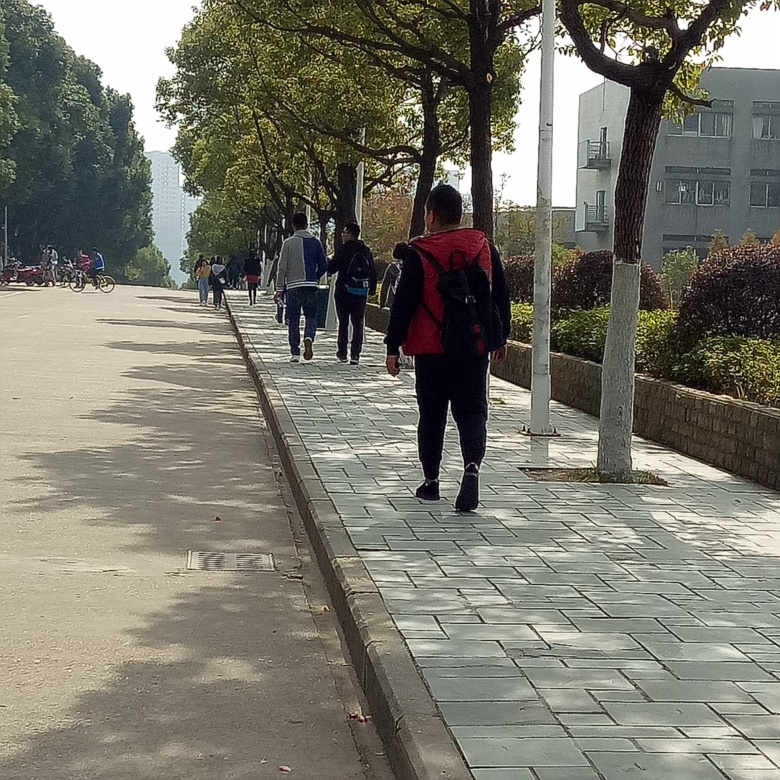What suggestions do you have to make this photo more visually interesting? To make the photo more visually interesting, one might wait for a moment of interaction or movement, such as a person sitting and reading under a tree, or a cyclist in motion. Playing with light and shadow, perhaps early in the morning or late in the afternoon, can also add drama and contrast to the scene. 